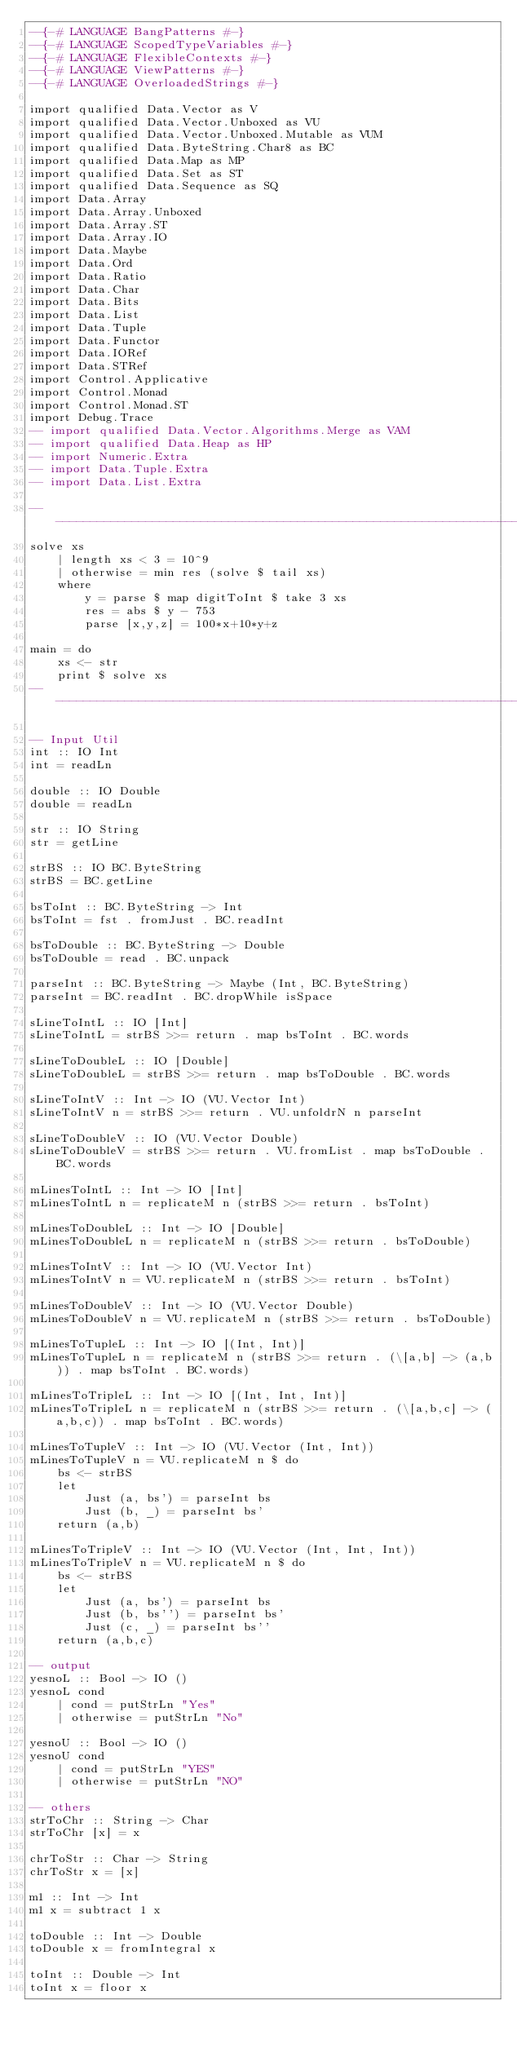<code> <loc_0><loc_0><loc_500><loc_500><_Haskell_>--{-# LANGUAGE BangPatterns #-}
--{-# LANGUAGE ScopedTypeVariables #-}
--{-# LANGUAGE FlexibleContexts #-}
--{-# LANGUAGE ViewPatterns #-}
--{-# LANGUAGE OverloadedStrings #-}

import qualified Data.Vector as V
import qualified Data.Vector.Unboxed as VU
import qualified Data.Vector.Unboxed.Mutable as VUM
import qualified Data.ByteString.Char8 as BC
import qualified Data.Map as MP
import qualified Data.Set as ST
import qualified Data.Sequence as SQ
import Data.Array
import Data.Array.Unboxed
import Data.Array.ST
import Data.Array.IO
import Data.Maybe
import Data.Ord
import Data.Ratio
import Data.Char
import Data.Bits
import Data.List
import Data.Tuple
import Data.Functor
import Data.IORef
import Data.STRef
import Control.Applicative
import Control.Monad
import Control.Monad.ST
import Debug.Trace
-- import qualified Data.Vector.Algorithms.Merge as VAM
-- import qualified Data.Heap as HP
-- import Numeric.Extra
-- import Data.Tuple.Extra
-- import Data.List.Extra

--------------------------------------------------------------------------
solve xs 
    | length xs < 3 = 10^9
    | otherwise = min res (solve $ tail xs)
    where
        y = parse $ map digitToInt $ take 3 xs
        res = abs $ y - 753
        parse [x,y,z] = 100*x+10*y+z

main = do
    xs <- str
    print $ solve xs
--------------------------------------------------------------------------

-- Input Util
int :: IO Int
int = readLn 

double :: IO Double
double = readLn 

str :: IO String
str = getLine

strBS :: IO BC.ByteString
strBS = BC.getLine

bsToInt :: BC.ByteString -> Int
bsToInt = fst . fromJust . BC.readInt

bsToDouble :: BC.ByteString -> Double
bsToDouble = read . BC.unpack

parseInt :: BC.ByteString -> Maybe (Int, BC.ByteString)
parseInt = BC.readInt . BC.dropWhile isSpace

sLineToIntL :: IO [Int]
sLineToIntL = strBS >>= return . map bsToInt . BC.words

sLineToDoubleL :: IO [Double]
sLineToDoubleL = strBS >>= return . map bsToDouble . BC.words

sLineToIntV :: Int -> IO (VU.Vector Int)
sLineToIntV n = strBS >>= return . VU.unfoldrN n parseInt

sLineToDoubleV :: IO (VU.Vector Double)
sLineToDoubleV = strBS >>= return . VU.fromList . map bsToDouble . BC.words

mLinesToIntL :: Int -> IO [Int]
mLinesToIntL n = replicateM n (strBS >>= return . bsToInt)

mLinesToDoubleL :: Int -> IO [Double]
mLinesToDoubleL n = replicateM n (strBS >>= return . bsToDouble)

mLinesToIntV :: Int -> IO (VU.Vector Int)
mLinesToIntV n = VU.replicateM n (strBS >>= return . bsToInt)

mLinesToDoubleV :: Int -> IO (VU.Vector Double)
mLinesToDoubleV n = VU.replicateM n (strBS >>= return . bsToDouble)

mLinesToTupleL :: Int -> IO [(Int, Int)]
mLinesToTupleL n = replicateM n (strBS >>= return . (\[a,b] -> (a,b)) . map bsToInt . BC.words)

mLinesToTripleL :: Int -> IO [(Int, Int, Int)]
mLinesToTripleL n = replicateM n (strBS >>= return . (\[a,b,c] -> (a,b,c)) . map bsToInt . BC.words)

mLinesToTupleV :: Int -> IO (VU.Vector (Int, Int))
mLinesToTupleV n = VU.replicateM n $ do
    bs <- strBS
    let
        Just (a, bs') = parseInt bs
        Just (b, _) = parseInt bs'
    return (a,b)
    
mLinesToTripleV :: Int -> IO (VU.Vector (Int, Int, Int))
mLinesToTripleV n = VU.replicateM n $ do
    bs <- strBS
    let
        Just (a, bs') = parseInt bs
        Just (b, bs'') = parseInt bs'
        Just (c, _) = parseInt bs''
    return (a,b,c)

-- output
yesnoL :: Bool -> IO ()
yesnoL cond
    | cond = putStrLn "Yes"
    | otherwise = putStrLn "No"

yesnoU :: Bool -> IO ()
yesnoU cond
    | cond = putStrLn "YES"
    | otherwise = putStrLn "NO"

-- others
strToChr :: String -> Char
strToChr [x] = x

chrToStr :: Char -> String
chrToStr x = [x]

m1 :: Int -> Int
m1 x = subtract 1 x

toDouble :: Int -> Double
toDouble x = fromIntegral x

toInt :: Double -> Int
toInt x = floor x</code> 